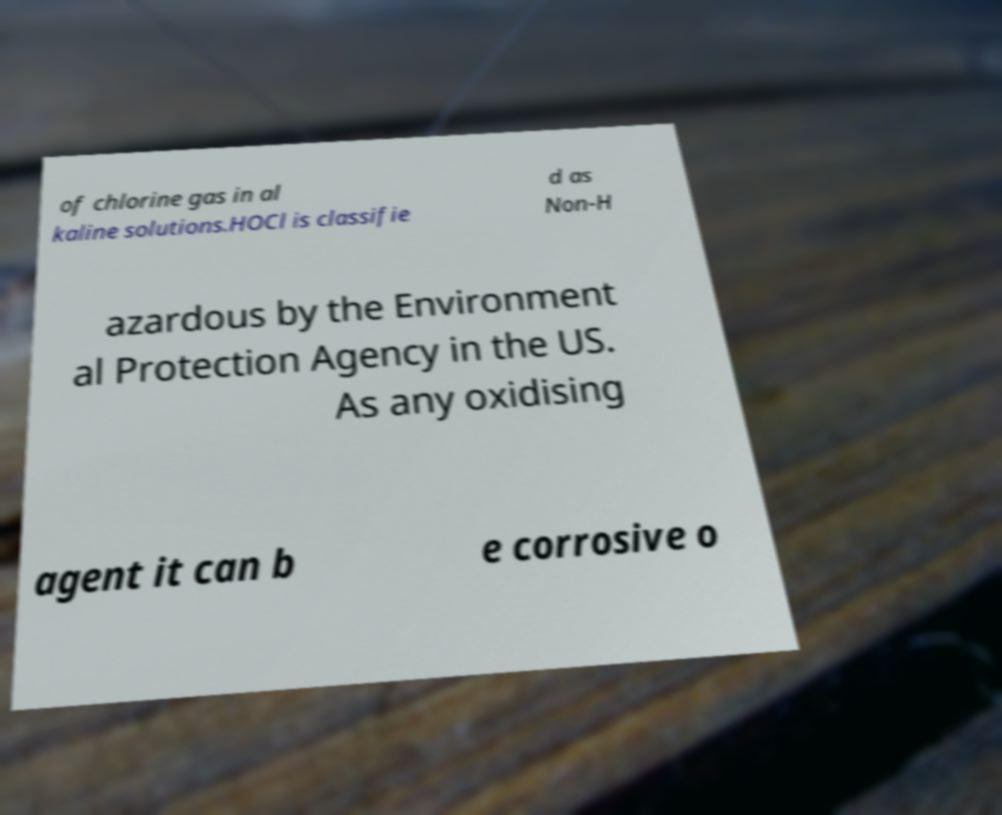Can you accurately transcribe the text from the provided image for me? of chlorine gas in al kaline solutions.HOCl is classifie d as Non-H azardous by the Environment al Protection Agency in the US. As any oxidising agent it can b e corrosive o 